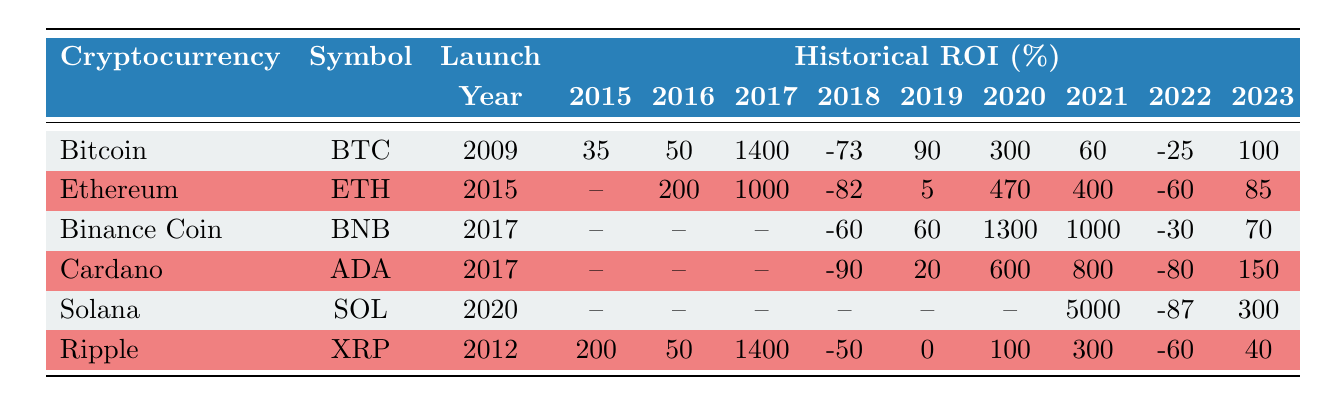What is the Historical ROI for Bitcoin in 2017? From the table, looking at the row for Bitcoin under the year 2017, the ROI is listed as 1400%.
Answer: 1400 Which cryptocurrency had the highest Historical ROI in 2021? By examining the table, we see that Solana's ROI in 2021 is 5000%, which is greater than any other cryptocurrency's ROI for that year.
Answer: Solana Is the Historical ROI for Cardano in 2018 less than 0%? The table shows Cardano's ROI for 2018 is -90%, which is indeed less than 0%.
Answer: Yes What was the average Historical ROI for Ethereum from 2016 to 2023? The ROI values from 2016 to 2023 are: 200, 1000, -82, 5, 470, 400, -60, and 85. Summing these yields 1618, and there are 8 values, so average = 1618/8 = 202.25.
Answer: 202.25 Did Ripple outperform Bitcoin in 2023? The table indicates Ripple's ROI in 2023 is 40% while Bitcoin's ROI is 100%. Therefore, Ripple did not outperform Bitcoin that year.
Answer: No Which altcoin has an ROI of more than 1000% in any year? From the table, Binance Coin has an ROI of 1300% in 2020, and Solana has an ROI of 5000% in 2021. Both are more than 1000%.
Answer: Yes What is the total Historical ROI for Binance Coin from 2019 to 2023? Looking at Binance Coin's ROIs from 2019 (60), 2020 (1300), 2021 (1000), 2022 (-30), and 2023 (70), we sum them: 60 + 1300 + 1000 - 30 + 70 = 2400.
Answer: 2400 Which cryptocurrency experienced the lowest Historical ROI in 2022? By checking the table, Cardano has the lowest ROI listed for 2022 at -80%.
Answer: Cardano What is the difference between the Historical ROIs of Ethereum in 2021 and 2022? Ethereum's ROI in 2021 is 400%, and in 2022 it is -60%. The difference is calculated as 400 - (-60) = 460.
Answer: 460 